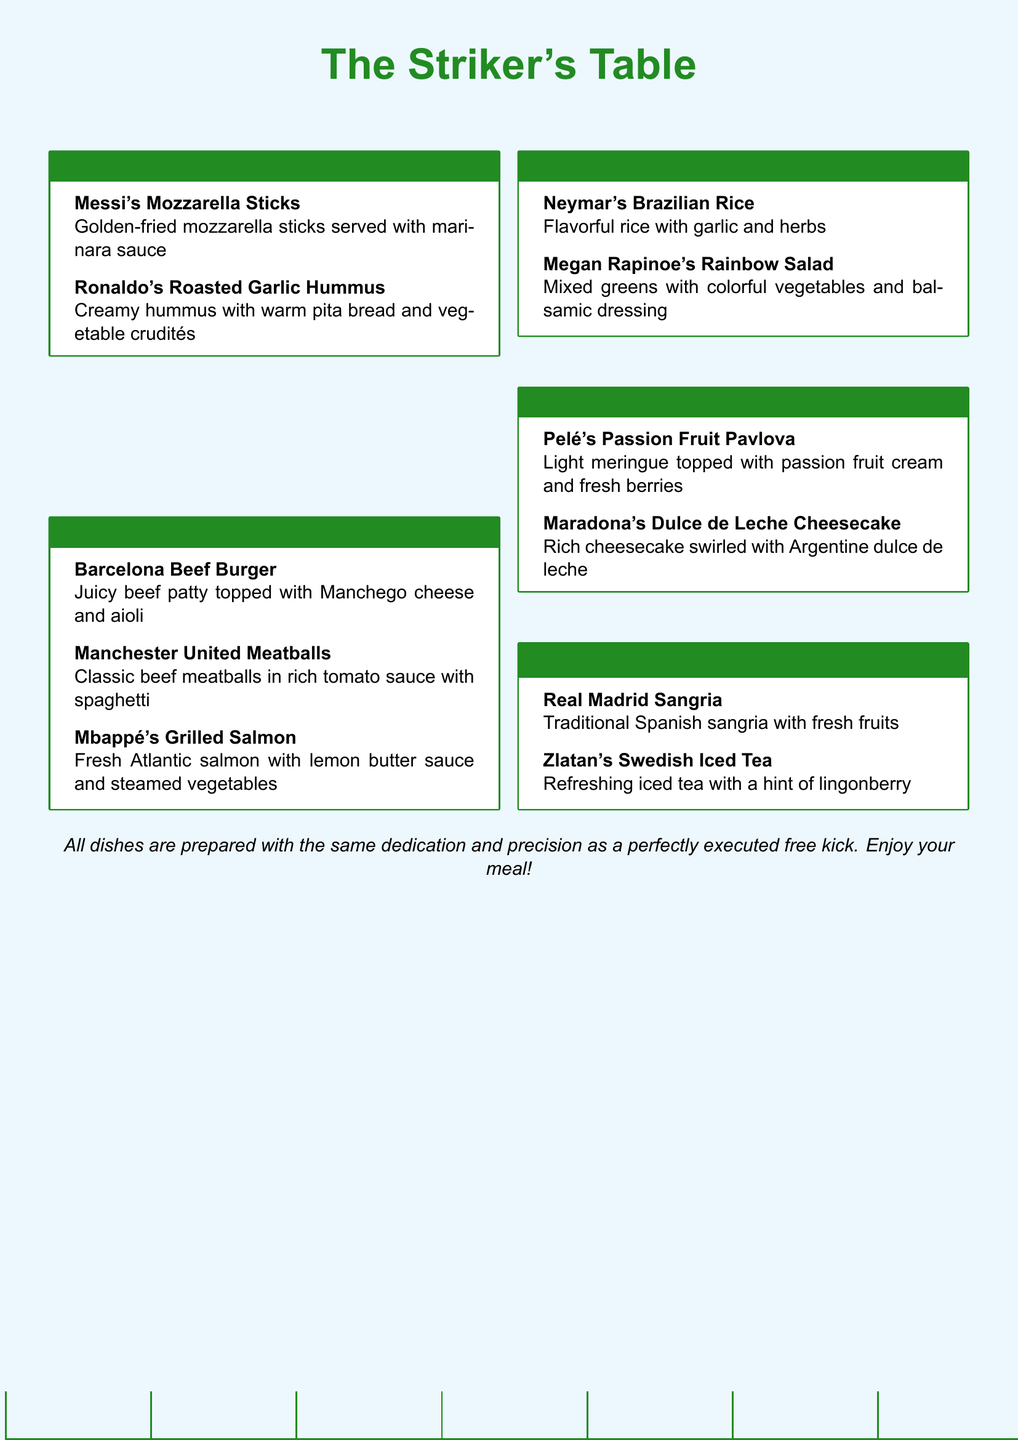what is the name of a starter dish that features mozzarella? The document lists "Messi's Mozzarella Sticks" as a starter dish featuring mozzarella.
Answer: Messi's Mozzarella Sticks which main course includes salmon? The dish "Mbappé's Grilled Salmon" is a main course that includes salmon.
Answer: Mbappé's Grilled Salmon how many types of desserts are listed in the menu? There are two dessert options provided in the menu: "Pelé's Passion Fruit Pavlova" and "Maradona's Dulce de Leche Cheesecake."
Answer: 2 what beverage is named after Real Madrid? The beverage "Real Madrid Sangria" is named after the famous soccer team.
Answer: Real Madrid Sangria what starter features garlic? "Ronaldo's Roasted Garlic Hummus" is the starter that features garlic.
Answer: Ronaldo's Roasted Garlic Hummus which dish is associated with Megan Rapinoe? The dish associated with Megan Rapinoe is "Megan Rapinoe's Rainbow Salad."
Answer: Megan Rapinoe's Rainbow Salad what type of cuisine is the "Barcelona Beef Burger"? The "Barcelona Beef Burger" is categorized as a main course in the restaurant menu, reflecting Spanish cuisine.
Answer: main course which ingredient is highlighted in "Neymar's Brazilian Rice"? "Neymar's Brazilian Rice" highlights garlic and herbs as its primary ingredients.
Answer: garlic and herbs 